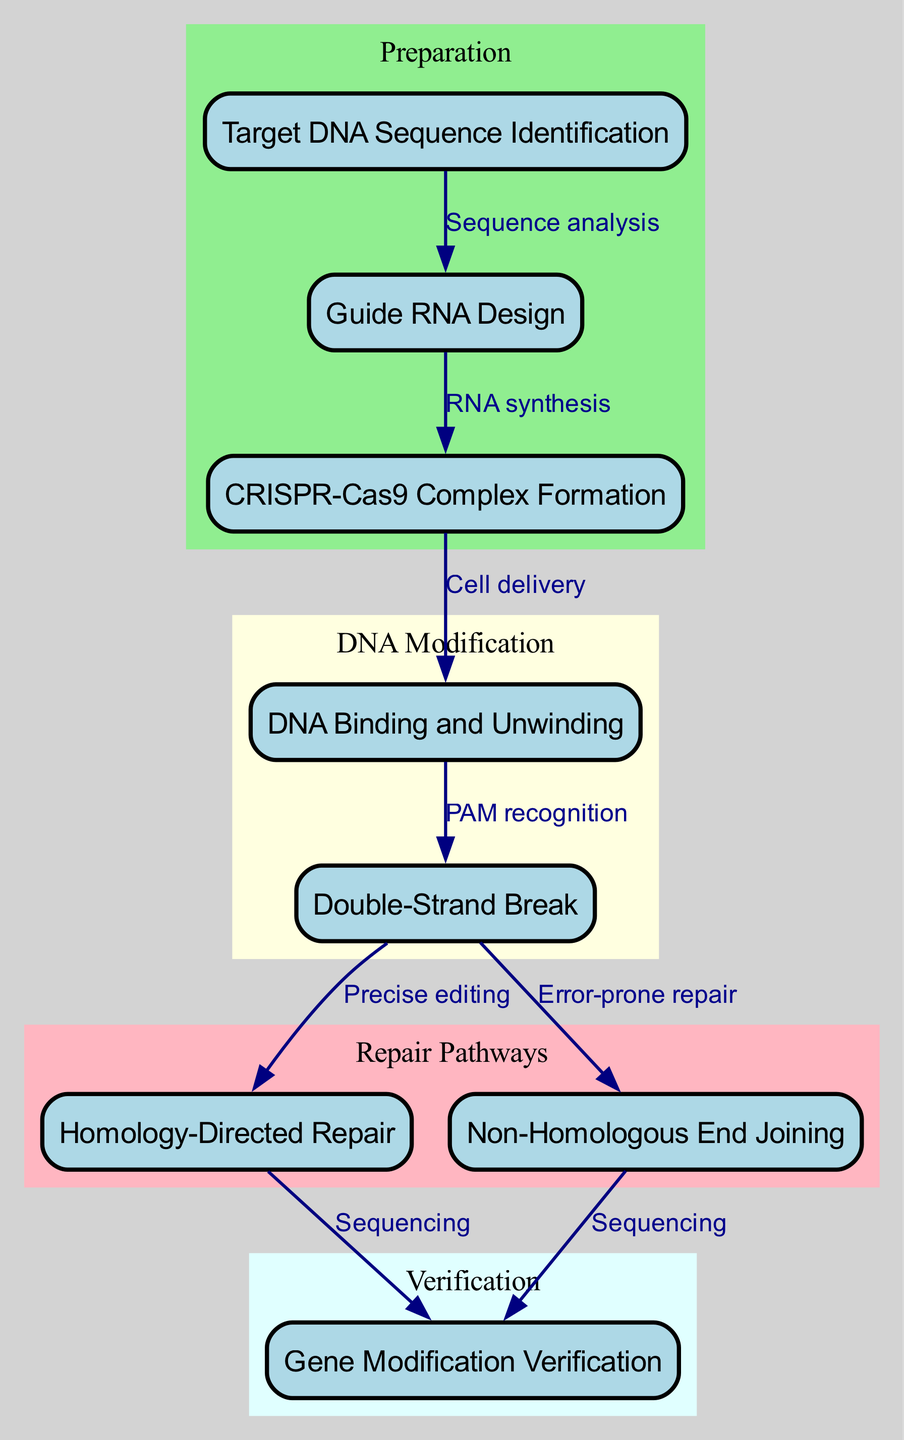What is the starting point of the gene editing process? The starting point is "Target DNA Sequence Identification," indicated as the first node in the diagram. This node is critical as it identifies the specific DNA sequence targeted for editing.
Answer: Target DNA Sequence Identification How many nodes are present in the diagram? The diagram contains eight nodes, each representing critical steps in the CRISPR-Cas9 gene editing process. Each node encapsulates a vital phase of the workflow.
Answer: 8 What is the relationship between "CRISPR-Cas9 Complex Formation" and "DNA Binding and Unwinding"? The relationship is defined as "Cell delivery," indicating that the CRISPR-Cas9 complex facilitates the delivery of the gene-editing tools to the DNA target, enabling the subsequent unwinding.
Answer: Cell delivery Which repair pathway involves "Precise editing"? "Precise editing" is part of the "Homology-Directed Repair" pathway, which is aimed at accurately incorporating intended changes at the double-strand breaks induced in the DNA.
Answer: Homology-Directed Repair What are the two possible outcomes after a double-strand break? The two outcomes are "Homology-Directed Repair" and "Non-Homologous End Joining," indicating the two main pathways the cell can take to repair the break.
Answer: Homology-Directed Repair and Non-Homologous End Joining In which phase is gene modification verification conducted? Gene modification verification is conducted in the "Verification" phase, represented by the last node in the diagram. This phase ensures that the intended edits have been successfully integrated.
Answer: Verification How many edges connect the nodes within the "Repair Pathways" subgraph? There are two edges connecting the nodes within the "Repair Pathways" subgraph: one from "Double-Strand Break" to "Homology-Directed Repair," and another from "Double-Strand Break" to "Non-Homologous End Joining."
Answer: 2 What processes are involved in the transition from "Target DNA Sequence Identification" to "Guide RNA Design"? The process involved is "Sequence analysis," which is the necessary step to analyze the desired DNA sequence in order to develop an appropriate guide RNA for the editing process.
Answer: Sequence analysis Which node directly precedes the "Gene Modification Verification"? The "Gene Modification Verification" node is preceded by both "Homology-Directed Repair" and "Non-Homologous End Joining," as sequencing for verification can follow either repair outcome.
Answer: Homology-Directed Repair and Non-Homologous End Joining 